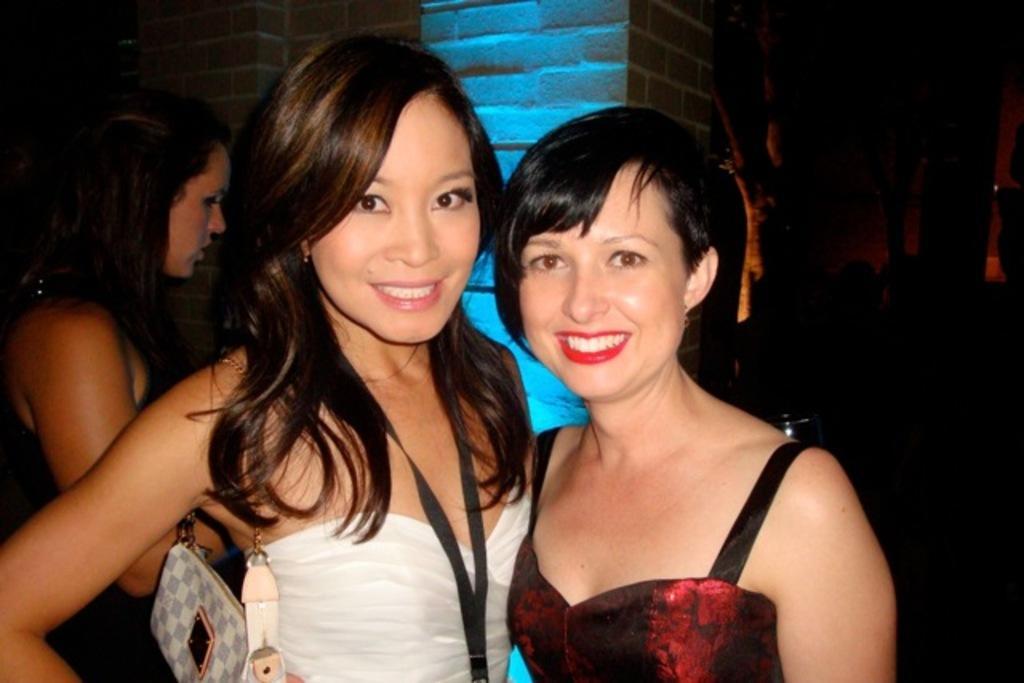Could you give a brief overview of what you see in this image? This picture seems to be clicked inside the room and we can see the group of people and we can see the three women wearing dresses and standing and we can see the sling bag. In the background we can see the pillar and some other items. 